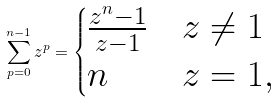Convert formula to latex. <formula><loc_0><loc_0><loc_500><loc_500>\sum _ { p = 0 } ^ { n - 1 } z ^ { p } = \begin{cases} \frac { z ^ { n } - 1 } { z - 1 } & z \neq 1 \\ n & z = 1 , \end{cases}</formula> 